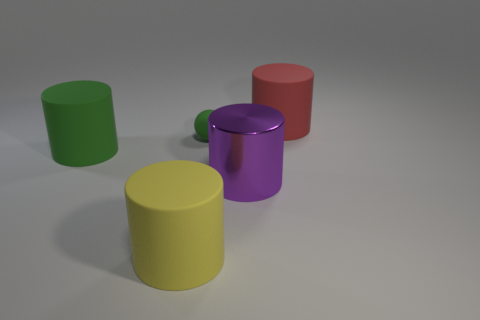How many other objects are there of the same material as the red thing?
Provide a short and direct response. 3. There is a large yellow rubber cylinder that is in front of the green object left of the matte ball; how many cylinders are on the right side of it?
Make the answer very short. 2. What number of rubber objects are either tiny green cubes or green cylinders?
Make the answer very short. 1. There is a matte thing on the left side of the matte object in front of the metal thing; what size is it?
Your answer should be compact. Large. There is a cylinder that is left of the big yellow rubber cylinder; does it have the same color as the rubber cylinder on the right side of the tiny green rubber object?
Offer a terse response. No. There is a cylinder that is both behind the large purple object and to the left of the metal thing; what is its color?
Your answer should be compact. Green. Do the tiny ball and the big red cylinder have the same material?
Your answer should be very brief. Yes. What number of big objects are either yellow rubber objects or green spheres?
Give a very brief answer. 1. Is there anything else that is the same shape as the purple metallic object?
Offer a terse response. Yes. Is there anything else that is the same size as the ball?
Ensure brevity in your answer.  No. 